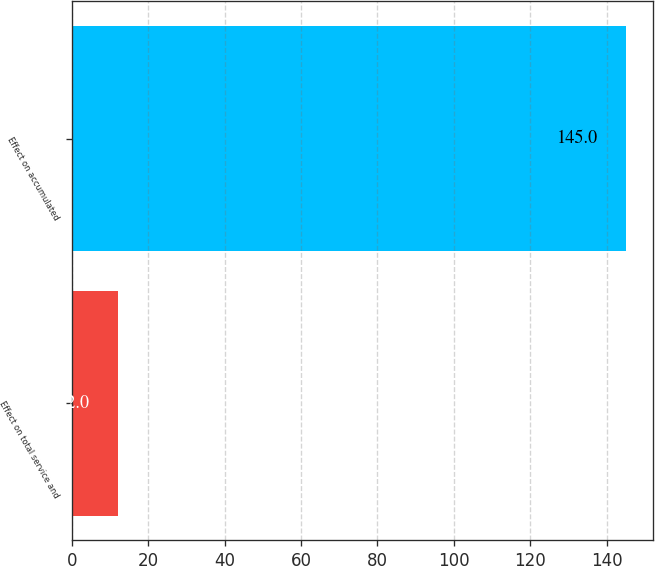Convert chart to OTSL. <chart><loc_0><loc_0><loc_500><loc_500><bar_chart><fcel>Effect on total service and<fcel>Effect on accumulated<nl><fcel>12<fcel>145<nl></chart> 